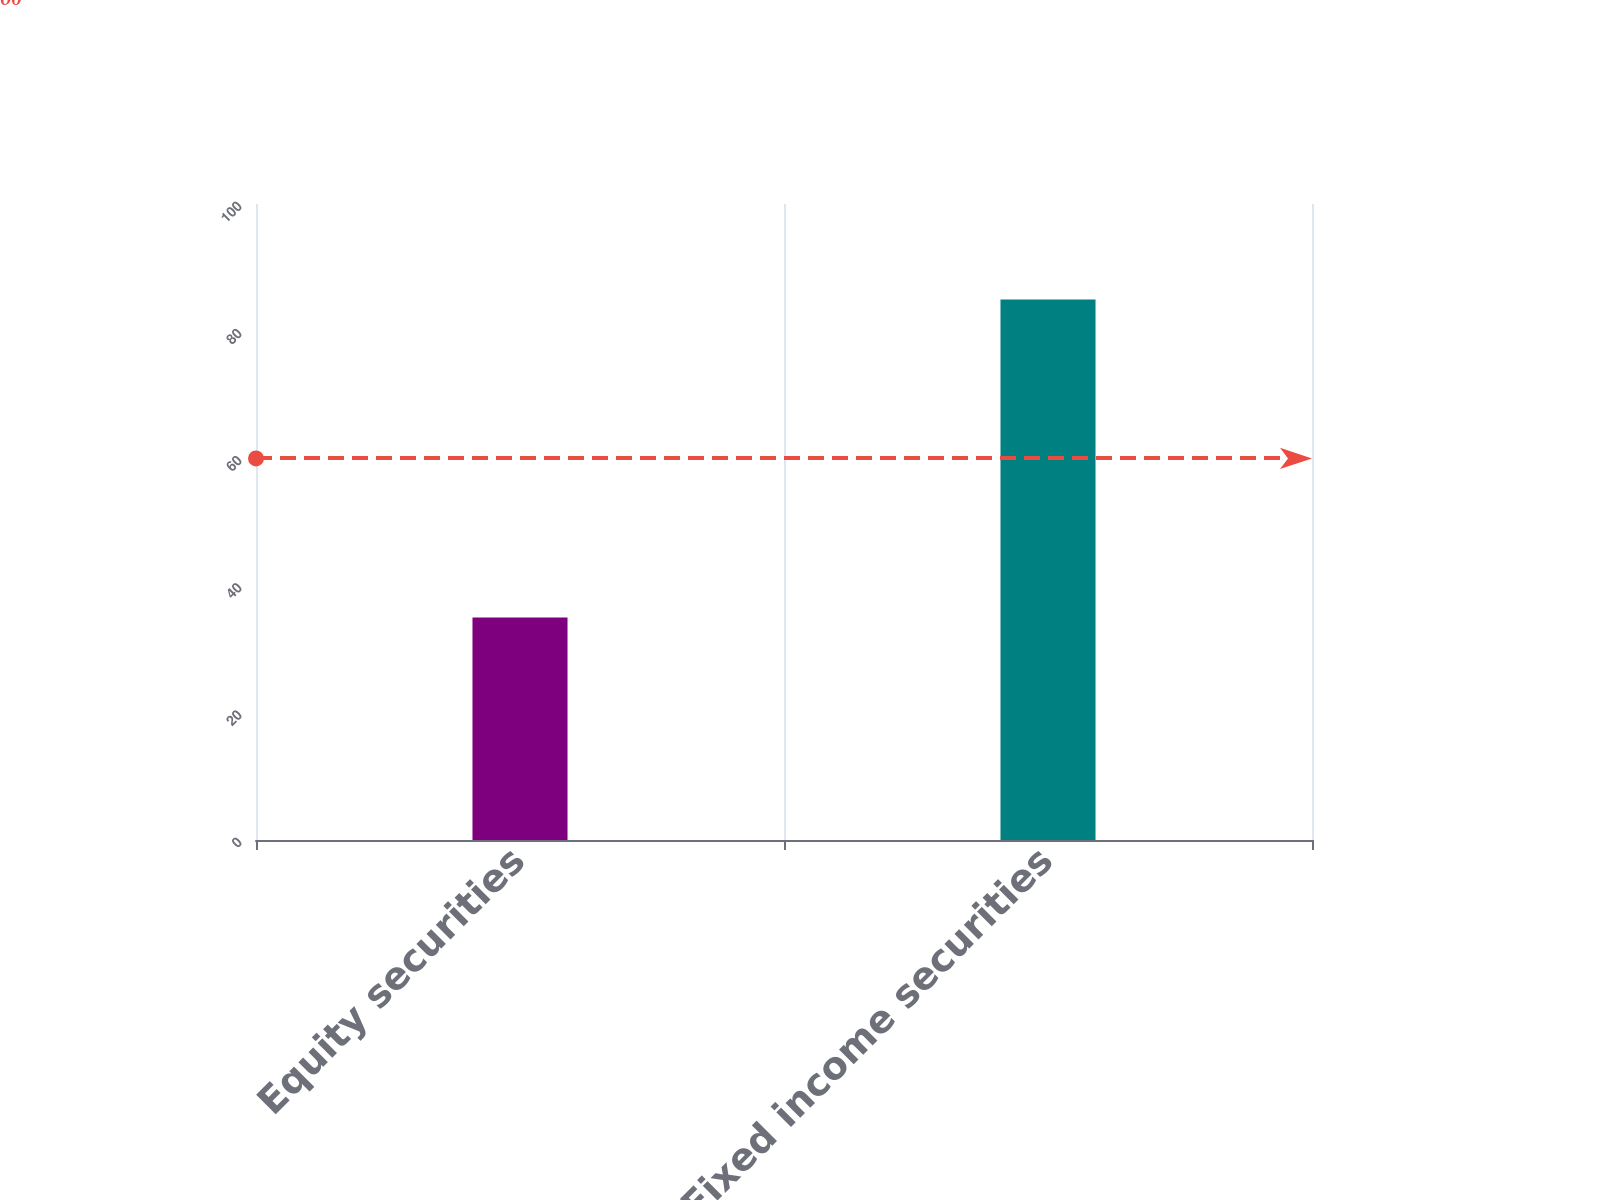<chart> <loc_0><loc_0><loc_500><loc_500><bar_chart><fcel>Equity securities<fcel>Fixed income securities<nl><fcel>35<fcel>85<nl></chart> 